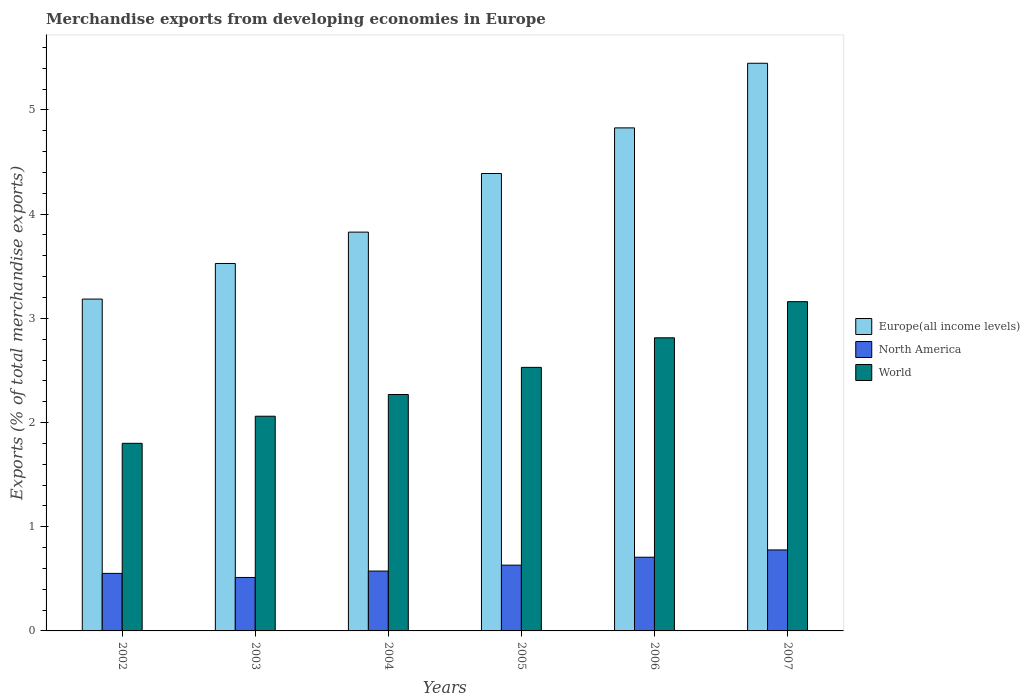How many groups of bars are there?
Give a very brief answer. 6. Are the number of bars per tick equal to the number of legend labels?
Provide a succinct answer. Yes. How many bars are there on the 6th tick from the left?
Your answer should be very brief. 3. How many bars are there on the 2nd tick from the right?
Offer a very short reply. 3. What is the label of the 1st group of bars from the left?
Your response must be concise. 2002. In how many cases, is the number of bars for a given year not equal to the number of legend labels?
Offer a terse response. 0. What is the percentage of total merchandise exports in Europe(all income levels) in 2006?
Ensure brevity in your answer.  4.83. Across all years, what is the maximum percentage of total merchandise exports in North America?
Ensure brevity in your answer.  0.78. Across all years, what is the minimum percentage of total merchandise exports in World?
Your response must be concise. 1.8. What is the total percentage of total merchandise exports in Europe(all income levels) in the graph?
Keep it short and to the point. 25.2. What is the difference between the percentage of total merchandise exports in World in 2006 and that in 2007?
Make the answer very short. -0.35. What is the difference between the percentage of total merchandise exports in Europe(all income levels) in 2007 and the percentage of total merchandise exports in North America in 2003?
Ensure brevity in your answer.  4.93. What is the average percentage of total merchandise exports in Europe(all income levels) per year?
Your answer should be compact. 4.2. In the year 2004, what is the difference between the percentage of total merchandise exports in World and percentage of total merchandise exports in Europe(all income levels)?
Provide a short and direct response. -1.56. In how many years, is the percentage of total merchandise exports in North America greater than 0.4 %?
Make the answer very short. 6. What is the ratio of the percentage of total merchandise exports in North America in 2002 to that in 2006?
Provide a succinct answer. 0.78. Is the percentage of total merchandise exports in Europe(all income levels) in 2005 less than that in 2006?
Provide a short and direct response. Yes. What is the difference between the highest and the second highest percentage of total merchandise exports in North America?
Ensure brevity in your answer.  0.07. What is the difference between the highest and the lowest percentage of total merchandise exports in North America?
Give a very brief answer. 0.26. In how many years, is the percentage of total merchandise exports in Europe(all income levels) greater than the average percentage of total merchandise exports in Europe(all income levels) taken over all years?
Your answer should be compact. 3. Is the sum of the percentage of total merchandise exports in World in 2002 and 2004 greater than the maximum percentage of total merchandise exports in North America across all years?
Keep it short and to the point. Yes. What does the 2nd bar from the right in 2004 represents?
Give a very brief answer. North America. How many years are there in the graph?
Offer a terse response. 6. Are the values on the major ticks of Y-axis written in scientific E-notation?
Provide a short and direct response. No. How are the legend labels stacked?
Your response must be concise. Vertical. What is the title of the graph?
Provide a succinct answer. Merchandise exports from developing economies in Europe. Does "Liechtenstein" appear as one of the legend labels in the graph?
Provide a succinct answer. No. What is the label or title of the X-axis?
Make the answer very short. Years. What is the label or title of the Y-axis?
Make the answer very short. Exports (% of total merchandise exports). What is the Exports (% of total merchandise exports) in Europe(all income levels) in 2002?
Provide a short and direct response. 3.18. What is the Exports (% of total merchandise exports) in North America in 2002?
Offer a terse response. 0.55. What is the Exports (% of total merchandise exports) in World in 2002?
Give a very brief answer. 1.8. What is the Exports (% of total merchandise exports) of Europe(all income levels) in 2003?
Provide a short and direct response. 3.53. What is the Exports (% of total merchandise exports) in North America in 2003?
Keep it short and to the point. 0.51. What is the Exports (% of total merchandise exports) in World in 2003?
Ensure brevity in your answer.  2.06. What is the Exports (% of total merchandise exports) of Europe(all income levels) in 2004?
Make the answer very short. 3.83. What is the Exports (% of total merchandise exports) in North America in 2004?
Provide a succinct answer. 0.57. What is the Exports (% of total merchandise exports) in World in 2004?
Provide a short and direct response. 2.27. What is the Exports (% of total merchandise exports) in Europe(all income levels) in 2005?
Offer a terse response. 4.39. What is the Exports (% of total merchandise exports) of North America in 2005?
Your answer should be very brief. 0.63. What is the Exports (% of total merchandise exports) of World in 2005?
Offer a terse response. 2.53. What is the Exports (% of total merchandise exports) of Europe(all income levels) in 2006?
Provide a short and direct response. 4.83. What is the Exports (% of total merchandise exports) in North America in 2006?
Keep it short and to the point. 0.71. What is the Exports (% of total merchandise exports) in World in 2006?
Provide a succinct answer. 2.81. What is the Exports (% of total merchandise exports) in Europe(all income levels) in 2007?
Your response must be concise. 5.45. What is the Exports (% of total merchandise exports) in North America in 2007?
Your answer should be compact. 0.78. What is the Exports (% of total merchandise exports) in World in 2007?
Your answer should be very brief. 3.16. Across all years, what is the maximum Exports (% of total merchandise exports) of Europe(all income levels)?
Your response must be concise. 5.45. Across all years, what is the maximum Exports (% of total merchandise exports) in North America?
Provide a short and direct response. 0.78. Across all years, what is the maximum Exports (% of total merchandise exports) of World?
Offer a very short reply. 3.16. Across all years, what is the minimum Exports (% of total merchandise exports) of Europe(all income levels)?
Offer a terse response. 3.18. Across all years, what is the minimum Exports (% of total merchandise exports) in North America?
Your answer should be very brief. 0.51. Across all years, what is the minimum Exports (% of total merchandise exports) of World?
Ensure brevity in your answer.  1.8. What is the total Exports (% of total merchandise exports) of Europe(all income levels) in the graph?
Provide a succinct answer. 25.2. What is the total Exports (% of total merchandise exports) of North America in the graph?
Make the answer very short. 3.76. What is the total Exports (% of total merchandise exports) of World in the graph?
Offer a terse response. 14.63. What is the difference between the Exports (% of total merchandise exports) in Europe(all income levels) in 2002 and that in 2003?
Your answer should be very brief. -0.34. What is the difference between the Exports (% of total merchandise exports) in North America in 2002 and that in 2003?
Your answer should be very brief. 0.04. What is the difference between the Exports (% of total merchandise exports) in World in 2002 and that in 2003?
Give a very brief answer. -0.26. What is the difference between the Exports (% of total merchandise exports) in Europe(all income levels) in 2002 and that in 2004?
Provide a succinct answer. -0.64. What is the difference between the Exports (% of total merchandise exports) in North America in 2002 and that in 2004?
Offer a very short reply. -0.02. What is the difference between the Exports (% of total merchandise exports) of World in 2002 and that in 2004?
Provide a succinct answer. -0.47. What is the difference between the Exports (% of total merchandise exports) in Europe(all income levels) in 2002 and that in 2005?
Your answer should be compact. -1.21. What is the difference between the Exports (% of total merchandise exports) of North America in 2002 and that in 2005?
Offer a very short reply. -0.08. What is the difference between the Exports (% of total merchandise exports) in World in 2002 and that in 2005?
Provide a short and direct response. -0.73. What is the difference between the Exports (% of total merchandise exports) in Europe(all income levels) in 2002 and that in 2006?
Your answer should be very brief. -1.64. What is the difference between the Exports (% of total merchandise exports) of North America in 2002 and that in 2006?
Provide a short and direct response. -0.16. What is the difference between the Exports (% of total merchandise exports) in World in 2002 and that in 2006?
Your answer should be compact. -1.01. What is the difference between the Exports (% of total merchandise exports) of Europe(all income levels) in 2002 and that in 2007?
Keep it short and to the point. -2.26. What is the difference between the Exports (% of total merchandise exports) in North America in 2002 and that in 2007?
Offer a very short reply. -0.23. What is the difference between the Exports (% of total merchandise exports) of World in 2002 and that in 2007?
Your response must be concise. -1.36. What is the difference between the Exports (% of total merchandise exports) of Europe(all income levels) in 2003 and that in 2004?
Make the answer very short. -0.3. What is the difference between the Exports (% of total merchandise exports) of North America in 2003 and that in 2004?
Provide a succinct answer. -0.06. What is the difference between the Exports (% of total merchandise exports) in World in 2003 and that in 2004?
Make the answer very short. -0.21. What is the difference between the Exports (% of total merchandise exports) in Europe(all income levels) in 2003 and that in 2005?
Give a very brief answer. -0.86. What is the difference between the Exports (% of total merchandise exports) of North America in 2003 and that in 2005?
Your answer should be compact. -0.12. What is the difference between the Exports (% of total merchandise exports) in World in 2003 and that in 2005?
Make the answer very short. -0.47. What is the difference between the Exports (% of total merchandise exports) in Europe(all income levels) in 2003 and that in 2006?
Ensure brevity in your answer.  -1.3. What is the difference between the Exports (% of total merchandise exports) in North America in 2003 and that in 2006?
Provide a succinct answer. -0.19. What is the difference between the Exports (% of total merchandise exports) in World in 2003 and that in 2006?
Keep it short and to the point. -0.75. What is the difference between the Exports (% of total merchandise exports) of Europe(all income levels) in 2003 and that in 2007?
Make the answer very short. -1.92. What is the difference between the Exports (% of total merchandise exports) in North America in 2003 and that in 2007?
Provide a short and direct response. -0.26. What is the difference between the Exports (% of total merchandise exports) in World in 2003 and that in 2007?
Keep it short and to the point. -1.1. What is the difference between the Exports (% of total merchandise exports) in Europe(all income levels) in 2004 and that in 2005?
Provide a succinct answer. -0.56. What is the difference between the Exports (% of total merchandise exports) in North America in 2004 and that in 2005?
Keep it short and to the point. -0.06. What is the difference between the Exports (% of total merchandise exports) in World in 2004 and that in 2005?
Offer a very short reply. -0.26. What is the difference between the Exports (% of total merchandise exports) in Europe(all income levels) in 2004 and that in 2006?
Ensure brevity in your answer.  -1. What is the difference between the Exports (% of total merchandise exports) in North America in 2004 and that in 2006?
Provide a succinct answer. -0.13. What is the difference between the Exports (% of total merchandise exports) of World in 2004 and that in 2006?
Ensure brevity in your answer.  -0.54. What is the difference between the Exports (% of total merchandise exports) of Europe(all income levels) in 2004 and that in 2007?
Ensure brevity in your answer.  -1.62. What is the difference between the Exports (% of total merchandise exports) in North America in 2004 and that in 2007?
Offer a very short reply. -0.2. What is the difference between the Exports (% of total merchandise exports) of World in 2004 and that in 2007?
Provide a succinct answer. -0.89. What is the difference between the Exports (% of total merchandise exports) in Europe(all income levels) in 2005 and that in 2006?
Offer a very short reply. -0.44. What is the difference between the Exports (% of total merchandise exports) in North America in 2005 and that in 2006?
Your answer should be very brief. -0.08. What is the difference between the Exports (% of total merchandise exports) of World in 2005 and that in 2006?
Make the answer very short. -0.28. What is the difference between the Exports (% of total merchandise exports) in Europe(all income levels) in 2005 and that in 2007?
Offer a very short reply. -1.06. What is the difference between the Exports (% of total merchandise exports) in North America in 2005 and that in 2007?
Offer a terse response. -0.15. What is the difference between the Exports (% of total merchandise exports) of World in 2005 and that in 2007?
Your answer should be compact. -0.63. What is the difference between the Exports (% of total merchandise exports) in Europe(all income levels) in 2006 and that in 2007?
Offer a very short reply. -0.62. What is the difference between the Exports (% of total merchandise exports) in North America in 2006 and that in 2007?
Your response must be concise. -0.07. What is the difference between the Exports (% of total merchandise exports) of World in 2006 and that in 2007?
Offer a terse response. -0.35. What is the difference between the Exports (% of total merchandise exports) of Europe(all income levels) in 2002 and the Exports (% of total merchandise exports) of North America in 2003?
Offer a very short reply. 2.67. What is the difference between the Exports (% of total merchandise exports) of Europe(all income levels) in 2002 and the Exports (% of total merchandise exports) of World in 2003?
Make the answer very short. 1.12. What is the difference between the Exports (% of total merchandise exports) of North America in 2002 and the Exports (% of total merchandise exports) of World in 2003?
Provide a short and direct response. -1.51. What is the difference between the Exports (% of total merchandise exports) of Europe(all income levels) in 2002 and the Exports (% of total merchandise exports) of North America in 2004?
Ensure brevity in your answer.  2.61. What is the difference between the Exports (% of total merchandise exports) of Europe(all income levels) in 2002 and the Exports (% of total merchandise exports) of World in 2004?
Keep it short and to the point. 0.92. What is the difference between the Exports (% of total merchandise exports) in North America in 2002 and the Exports (% of total merchandise exports) in World in 2004?
Keep it short and to the point. -1.72. What is the difference between the Exports (% of total merchandise exports) of Europe(all income levels) in 2002 and the Exports (% of total merchandise exports) of North America in 2005?
Give a very brief answer. 2.55. What is the difference between the Exports (% of total merchandise exports) of Europe(all income levels) in 2002 and the Exports (% of total merchandise exports) of World in 2005?
Provide a short and direct response. 0.66. What is the difference between the Exports (% of total merchandise exports) of North America in 2002 and the Exports (% of total merchandise exports) of World in 2005?
Make the answer very short. -1.98. What is the difference between the Exports (% of total merchandise exports) of Europe(all income levels) in 2002 and the Exports (% of total merchandise exports) of North America in 2006?
Offer a very short reply. 2.48. What is the difference between the Exports (% of total merchandise exports) of Europe(all income levels) in 2002 and the Exports (% of total merchandise exports) of World in 2006?
Keep it short and to the point. 0.37. What is the difference between the Exports (% of total merchandise exports) of North America in 2002 and the Exports (% of total merchandise exports) of World in 2006?
Provide a succinct answer. -2.26. What is the difference between the Exports (% of total merchandise exports) in Europe(all income levels) in 2002 and the Exports (% of total merchandise exports) in North America in 2007?
Ensure brevity in your answer.  2.41. What is the difference between the Exports (% of total merchandise exports) of Europe(all income levels) in 2002 and the Exports (% of total merchandise exports) of World in 2007?
Provide a short and direct response. 0.02. What is the difference between the Exports (% of total merchandise exports) of North America in 2002 and the Exports (% of total merchandise exports) of World in 2007?
Offer a very short reply. -2.61. What is the difference between the Exports (% of total merchandise exports) of Europe(all income levels) in 2003 and the Exports (% of total merchandise exports) of North America in 2004?
Offer a terse response. 2.95. What is the difference between the Exports (% of total merchandise exports) in Europe(all income levels) in 2003 and the Exports (% of total merchandise exports) in World in 2004?
Keep it short and to the point. 1.26. What is the difference between the Exports (% of total merchandise exports) in North America in 2003 and the Exports (% of total merchandise exports) in World in 2004?
Offer a terse response. -1.76. What is the difference between the Exports (% of total merchandise exports) in Europe(all income levels) in 2003 and the Exports (% of total merchandise exports) in North America in 2005?
Provide a short and direct response. 2.9. What is the difference between the Exports (% of total merchandise exports) of North America in 2003 and the Exports (% of total merchandise exports) of World in 2005?
Your answer should be compact. -2.02. What is the difference between the Exports (% of total merchandise exports) of Europe(all income levels) in 2003 and the Exports (% of total merchandise exports) of North America in 2006?
Offer a terse response. 2.82. What is the difference between the Exports (% of total merchandise exports) in Europe(all income levels) in 2003 and the Exports (% of total merchandise exports) in World in 2006?
Your answer should be very brief. 0.71. What is the difference between the Exports (% of total merchandise exports) in North America in 2003 and the Exports (% of total merchandise exports) in World in 2006?
Ensure brevity in your answer.  -2.3. What is the difference between the Exports (% of total merchandise exports) in Europe(all income levels) in 2003 and the Exports (% of total merchandise exports) in North America in 2007?
Provide a short and direct response. 2.75. What is the difference between the Exports (% of total merchandise exports) in Europe(all income levels) in 2003 and the Exports (% of total merchandise exports) in World in 2007?
Provide a succinct answer. 0.37. What is the difference between the Exports (% of total merchandise exports) of North America in 2003 and the Exports (% of total merchandise exports) of World in 2007?
Offer a terse response. -2.65. What is the difference between the Exports (% of total merchandise exports) of Europe(all income levels) in 2004 and the Exports (% of total merchandise exports) of North America in 2005?
Give a very brief answer. 3.2. What is the difference between the Exports (% of total merchandise exports) of Europe(all income levels) in 2004 and the Exports (% of total merchandise exports) of World in 2005?
Make the answer very short. 1.3. What is the difference between the Exports (% of total merchandise exports) in North America in 2004 and the Exports (% of total merchandise exports) in World in 2005?
Your answer should be very brief. -1.95. What is the difference between the Exports (% of total merchandise exports) of Europe(all income levels) in 2004 and the Exports (% of total merchandise exports) of North America in 2006?
Give a very brief answer. 3.12. What is the difference between the Exports (% of total merchandise exports) in Europe(all income levels) in 2004 and the Exports (% of total merchandise exports) in World in 2006?
Give a very brief answer. 1.01. What is the difference between the Exports (% of total merchandise exports) in North America in 2004 and the Exports (% of total merchandise exports) in World in 2006?
Your answer should be very brief. -2.24. What is the difference between the Exports (% of total merchandise exports) in Europe(all income levels) in 2004 and the Exports (% of total merchandise exports) in North America in 2007?
Provide a succinct answer. 3.05. What is the difference between the Exports (% of total merchandise exports) in Europe(all income levels) in 2004 and the Exports (% of total merchandise exports) in World in 2007?
Offer a very short reply. 0.67. What is the difference between the Exports (% of total merchandise exports) of North America in 2004 and the Exports (% of total merchandise exports) of World in 2007?
Offer a terse response. -2.59. What is the difference between the Exports (% of total merchandise exports) of Europe(all income levels) in 2005 and the Exports (% of total merchandise exports) of North America in 2006?
Provide a short and direct response. 3.68. What is the difference between the Exports (% of total merchandise exports) in Europe(all income levels) in 2005 and the Exports (% of total merchandise exports) in World in 2006?
Provide a succinct answer. 1.58. What is the difference between the Exports (% of total merchandise exports) of North America in 2005 and the Exports (% of total merchandise exports) of World in 2006?
Provide a succinct answer. -2.18. What is the difference between the Exports (% of total merchandise exports) in Europe(all income levels) in 2005 and the Exports (% of total merchandise exports) in North America in 2007?
Provide a succinct answer. 3.61. What is the difference between the Exports (% of total merchandise exports) of Europe(all income levels) in 2005 and the Exports (% of total merchandise exports) of World in 2007?
Your answer should be compact. 1.23. What is the difference between the Exports (% of total merchandise exports) in North America in 2005 and the Exports (% of total merchandise exports) in World in 2007?
Your answer should be very brief. -2.53. What is the difference between the Exports (% of total merchandise exports) of Europe(all income levels) in 2006 and the Exports (% of total merchandise exports) of North America in 2007?
Give a very brief answer. 4.05. What is the difference between the Exports (% of total merchandise exports) in Europe(all income levels) in 2006 and the Exports (% of total merchandise exports) in World in 2007?
Offer a very short reply. 1.67. What is the difference between the Exports (% of total merchandise exports) of North America in 2006 and the Exports (% of total merchandise exports) of World in 2007?
Provide a succinct answer. -2.45. What is the average Exports (% of total merchandise exports) of Europe(all income levels) per year?
Your answer should be compact. 4.2. What is the average Exports (% of total merchandise exports) in North America per year?
Your answer should be compact. 0.63. What is the average Exports (% of total merchandise exports) in World per year?
Ensure brevity in your answer.  2.44. In the year 2002, what is the difference between the Exports (% of total merchandise exports) of Europe(all income levels) and Exports (% of total merchandise exports) of North America?
Your response must be concise. 2.63. In the year 2002, what is the difference between the Exports (% of total merchandise exports) in Europe(all income levels) and Exports (% of total merchandise exports) in World?
Provide a succinct answer. 1.38. In the year 2002, what is the difference between the Exports (% of total merchandise exports) of North America and Exports (% of total merchandise exports) of World?
Make the answer very short. -1.25. In the year 2003, what is the difference between the Exports (% of total merchandise exports) of Europe(all income levels) and Exports (% of total merchandise exports) of North America?
Offer a terse response. 3.01. In the year 2003, what is the difference between the Exports (% of total merchandise exports) of Europe(all income levels) and Exports (% of total merchandise exports) of World?
Offer a very short reply. 1.47. In the year 2003, what is the difference between the Exports (% of total merchandise exports) in North America and Exports (% of total merchandise exports) in World?
Your answer should be compact. -1.55. In the year 2004, what is the difference between the Exports (% of total merchandise exports) in Europe(all income levels) and Exports (% of total merchandise exports) in North America?
Your answer should be compact. 3.25. In the year 2004, what is the difference between the Exports (% of total merchandise exports) in Europe(all income levels) and Exports (% of total merchandise exports) in World?
Provide a short and direct response. 1.56. In the year 2004, what is the difference between the Exports (% of total merchandise exports) in North America and Exports (% of total merchandise exports) in World?
Provide a short and direct response. -1.69. In the year 2005, what is the difference between the Exports (% of total merchandise exports) in Europe(all income levels) and Exports (% of total merchandise exports) in North America?
Your answer should be compact. 3.76. In the year 2005, what is the difference between the Exports (% of total merchandise exports) of Europe(all income levels) and Exports (% of total merchandise exports) of World?
Offer a very short reply. 1.86. In the year 2005, what is the difference between the Exports (% of total merchandise exports) in North America and Exports (% of total merchandise exports) in World?
Your answer should be compact. -1.9. In the year 2006, what is the difference between the Exports (% of total merchandise exports) of Europe(all income levels) and Exports (% of total merchandise exports) of North America?
Give a very brief answer. 4.12. In the year 2006, what is the difference between the Exports (% of total merchandise exports) in Europe(all income levels) and Exports (% of total merchandise exports) in World?
Your answer should be very brief. 2.01. In the year 2006, what is the difference between the Exports (% of total merchandise exports) in North America and Exports (% of total merchandise exports) in World?
Ensure brevity in your answer.  -2.11. In the year 2007, what is the difference between the Exports (% of total merchandise exports) of Europe(all income levels) and Exports (% of total merchandise exports) of North America?
Provide a succinct answer. 4.67. In the year 2007, what is the difference between the Exports (% of total merchandise exports) of Europe(all income levels) and Exports (% of total merchandise exports) of World?
Provide a succinct answer. 2.29. In the year 2007, what is the difference between the Exports (% of total merchandise exports) in North America and Exports (% of total merchandise exports) in World?
Ensure brevity in your answer.  -2.38. What is the ratio of the Exports (% of total merchandise exports) of Europe(all income levels) in 2002 to that in 2003?
Make the answer very short. 0.9. What is the ratio of the Exports (% of total merchandise exports) in North America in 2002 to that in 2003?
Keep it short and to the point. 1.08. What is the ratio of the Exports (% of total merchandise exports) of World in 2002 to that in 2003?
Your response must be concise. 0.87. What is the ratio of the Exports (% of total merchandise exports) in Europe(all income levels) in 2002 to that in 2004?
Your answer should be compact. 0.83. What is the ratio of the Exports (% of total merchandise exports) in North America in 2002 to that in 2004?
Your answer should be compact. 0.96. What is the ratio of the Exports (% of total merchandise exports) of World in 2002 to that in 2004?
Ensure brevity in your answer.  0.79. What is the ratio of the Exports (% of total merchandise exports) in Europe(all income levels) in 2002 to that in 2005?
Make the answer very short. 0.73. What is the ratio of the Exports (% of total merchandise exports) in North America in 2002 to that in 2005?
Provide a short and direct response. 0.87. What is the ratio of the Exports (% of total merchandise exports) of World in 2002 to that in 2005?
Provide a short and direct response. 0.71. What is the ratio of the Exports (% of total merchandise exports) in Europe(all income levels) in 2002 to that in 2006?
Provide a succinct answer. 0.66. What is the ratio of the Exports (% of total merchandise exports) in North America in 2002 to that in 2006?
Provide a short and direct response. 0.78. What is the ratio of the Exports (% of total merchandise exports) of World in 2002 to that in 2006?
Provide a succinct answer. 0.64. What is the ratio of the Exports (% of total merchandise exports) in Europe(all income levels) in 2002 to that in 2007?
Make the answer very short. 0.58. What is the ratio of the Exports (% of total merchandise exports) in North America in 2002 to that in 2007?
Keep it short and to the point. 0.71. What is the ratio of the Exports (% of total merchandise exports) of World in 2002 to that in 2007?
Provide a succinct answer. 0.57. What is the ratio of the Exports (% of total merchandise exports) of Europe(all income levels) in 2003 to that in 2004?
Keep it short and to the point. 0.92. What is the ratio of the Exports (% of total merchandise exports) of North America in 2003 to that in 2004?
Offer a very short reply. 0.89. What is the ratio of the Exports (% of total merchandise exports) of World in 2003 to that in 2004?
Your answer should be very brief. 0.91. What is the ratio of the Exports (% of total merchandise exports) of Europe(all income levels) in 2003 to that in 2005?
Your answer should be very brief. 0.8. What is the ratio of the Exports (% of total merchandise exports) in North America in 2003 to that in 2005?
Your response must be concise. 0.81. What is the ratio of the Exports (% of total merchandise exports) of World in 2003 to that in 2005?
Offer a very short reply. 0.81. What is the ratio of the Exports (% of total merchandise exports) of Europe(all income levels) in 2003 to that in 2006?
Provide a short and direct response. 0.73. What is the ratio of the Exports (% of total merchandise exports) of North America in 2003 to that in 2006?
Provide a succinct answer. 0.73. What is the ratio of the Exports (% of total merchandise exports) in World in 2003 to that in 2006?
Your answer should be compact. 0.73. What is the ratio of the Exports (% of total merchandise exports) in Europe(all income levels) in 2003 to that in 2007?
Keep it short and to the point. 0.65. What is the ratio of the Exports (% of total merchandise exports) in North America in 2003 to that in 2007?
Offer a terse response. 0.66. What is the ratio of the Exports (% of total merchandise exports) of World in 2003 to that in 2007?
Provide a short and direct response. 0.65. What is the ratio of the Exports (% of total merchandise exports) in Europe(all income levels) in 2004 to that in 2005?
Give a very brief answer. 0.87. What is the ratio of the Exports (% of total merchandise exports) in North America in 2004 to that in 2005?
Keep it short and to the point. 0.91. What is the ratio of the Exports (% of total merchandise exports) in World in 2004 to that in 2005?
Provide a succinct answer. 0.9. What is the ratio of the Exports (% of total merchandise exports) in Europe(all income levels) in 2004 to that in 2006?
Keep it short and to the point. 0.79. What is the ratio of the Exports (% of total merchandise exports) of North America in 2004 to that in 2006?
Provide a short and direct response. 0.81. What is the ratio of the Exports (% of total merchandise exports) in World in 2004 to that in 2006?
Keep it short and to the point. 0.81. What is the ratio of the Exports (% of total merchandise exports) in Europe(all income levels) in 2004 to that in 2007?
Ensure brevity in your answer.  0.7. What is the ratio of the Exports (% of total merchandise exports) of North America in 2004 to that in 2007?
Your response must be concise. 0.74. What is the ratio of the Exports (% of total merchandise exports) in World in 2004 to that in 2007?
Make the answer very short. 0.72. What is the ratio of the Exports (% of total merchandise exports) of Europe(all income levels) in 2005 to that in 2006?
Offer a very short reply. 0.91. What is the ratio of the Exports (% of total merchandise exports) of North America in 2005 to that in 2006?
Provide a succinct answer. 0.89. What is the ratio of the Exports (% of total merchandise exports) of World in 2005 to that in 2006?
Provide a short and direct response. 0.9. What is the ratio of the Exports (% of total merchandise exports) in Europe(all income levels) in 2005 to that in 2007?
Offer a terse response. 0.81. What is the ratio of the Exports (% of total merchandise exports) of North America in 2005 to that in 2007?
Your response must be concise. 0.81. What is the ratio of the Exports (% of total merchandise exports) in World in 2005 to that in 2007?
Your answer should be compact. 0.8. What is the ratio of the Exports (% of total merchandise exports) in Europe(all income levels) in 2006 to that in 2007?
Provide a succinct answer. 0.89. What is the ratio of the Exports (% of total merchandise exports) in North America in 2006 to that in 2007?
Offer a very short reply. 0.91. What is the ratio of the Exports (% of total merchandise exports) of World in 2006 to that in 2007?
Give a very brief answer. 0.89. What is the difference between the highest and the second highest Exports (% of total merchandise exports) in Europe(all income levels)?
Provide a succinct answer. 0.62. What is the difference between the highest and the second highest Exports (% of total merchandise exports) of North America?
Offer a terse response. 0.07. What is the difference between the highest and the second highest Exports (% of total merchandise exports) in World?
Make the answer very short. 0.35. What is the difference between the highest and the lowest Exports (% of total merchandise exports) of Europe(all income levels)?
Your response must be concise. 2.26. What is the difference between the highest and the lowest Exports (% of total merchandise exports) in North America?
Your answer should be compact. 0.26. What is the difference between the highest and the lowest Exports (% of total merchandise exports) in World?
Offer a very short reply. 1.36. 